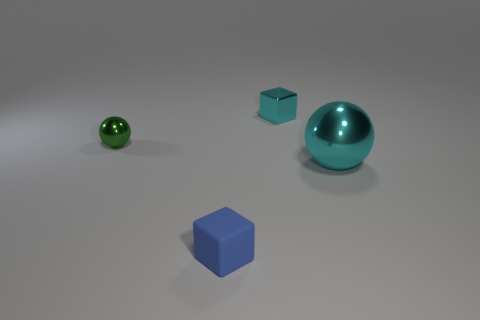Add 4 large yellow objects. How many objects exist? 8 Subtract 0 cyan cylinders. How many objects are left? 4 Subtract all blue cubes. Subtract all small spheres. How many objects are left? 2 Add 1 small cyan shiny things. How many small cyan shiny things are left? 2 Add 1 spheres. How many spheres exist? 3 